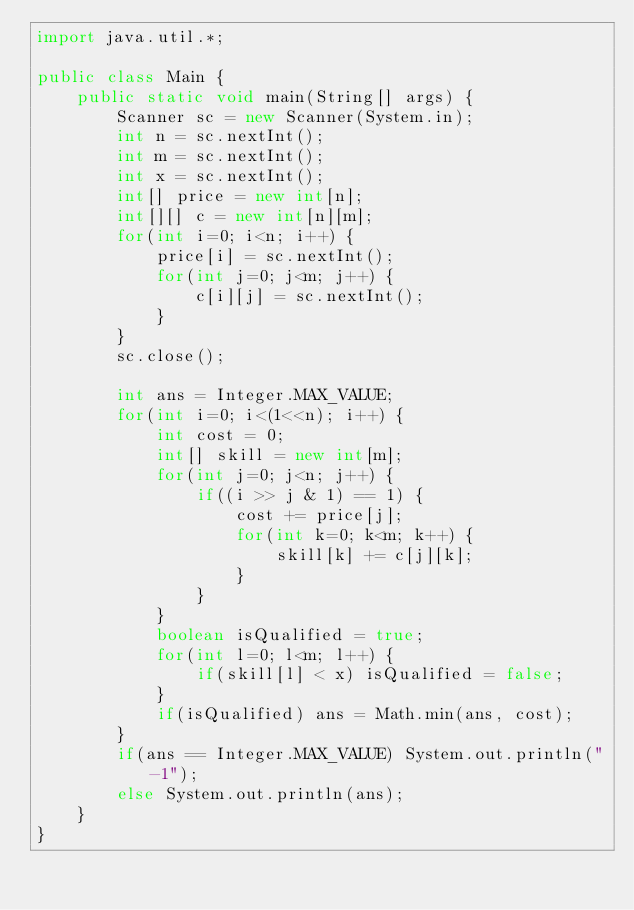<code> <loc_0><loc_0><loc_500><loc_500><_Java_>import java.util.*;

public class Main {
    public static void main(String[] args) {
        Scanner sc = new Scanner(System.in);
        int n = sc.nextInt();
        int m = sc.nextInt();
        int x = sc.nextInt();
        int[] price = new int[n];
        int[][] c = new int[n][m];
        for(int i=0; i<n; i++) {
            price[i] = sc.nextInt();
            for(int j=0; j<m; j++) {
                c[i][j] = sc.nextInt();
            }
        }
        sc.close();

        int ans = Integer.MAX_VALUE;
        for(int i=0; i<(1<<n); i++) {
            int cost = 0;
            int[] skill = new int[m];
            for(int j=0; j<n; j++) {
                if((i >> j & 1) == 1) {
                    cost += price[j];
                    for(int k=0; k<m; k++) {
                        skill[k] += c[j][k];
                    }
                }
            }
            boolean isQualified = true;
            for(int l=0; l<m; l++) {
                if(skill[l] < x) isQualified = false;
            }
            if(isQualified) ans = Math.min(ans, cost);
        }
        if(ans == Integer.MAX_VALUE) System.out.println("-1");
        else System.out.println(ans);
    }
}
</code> 